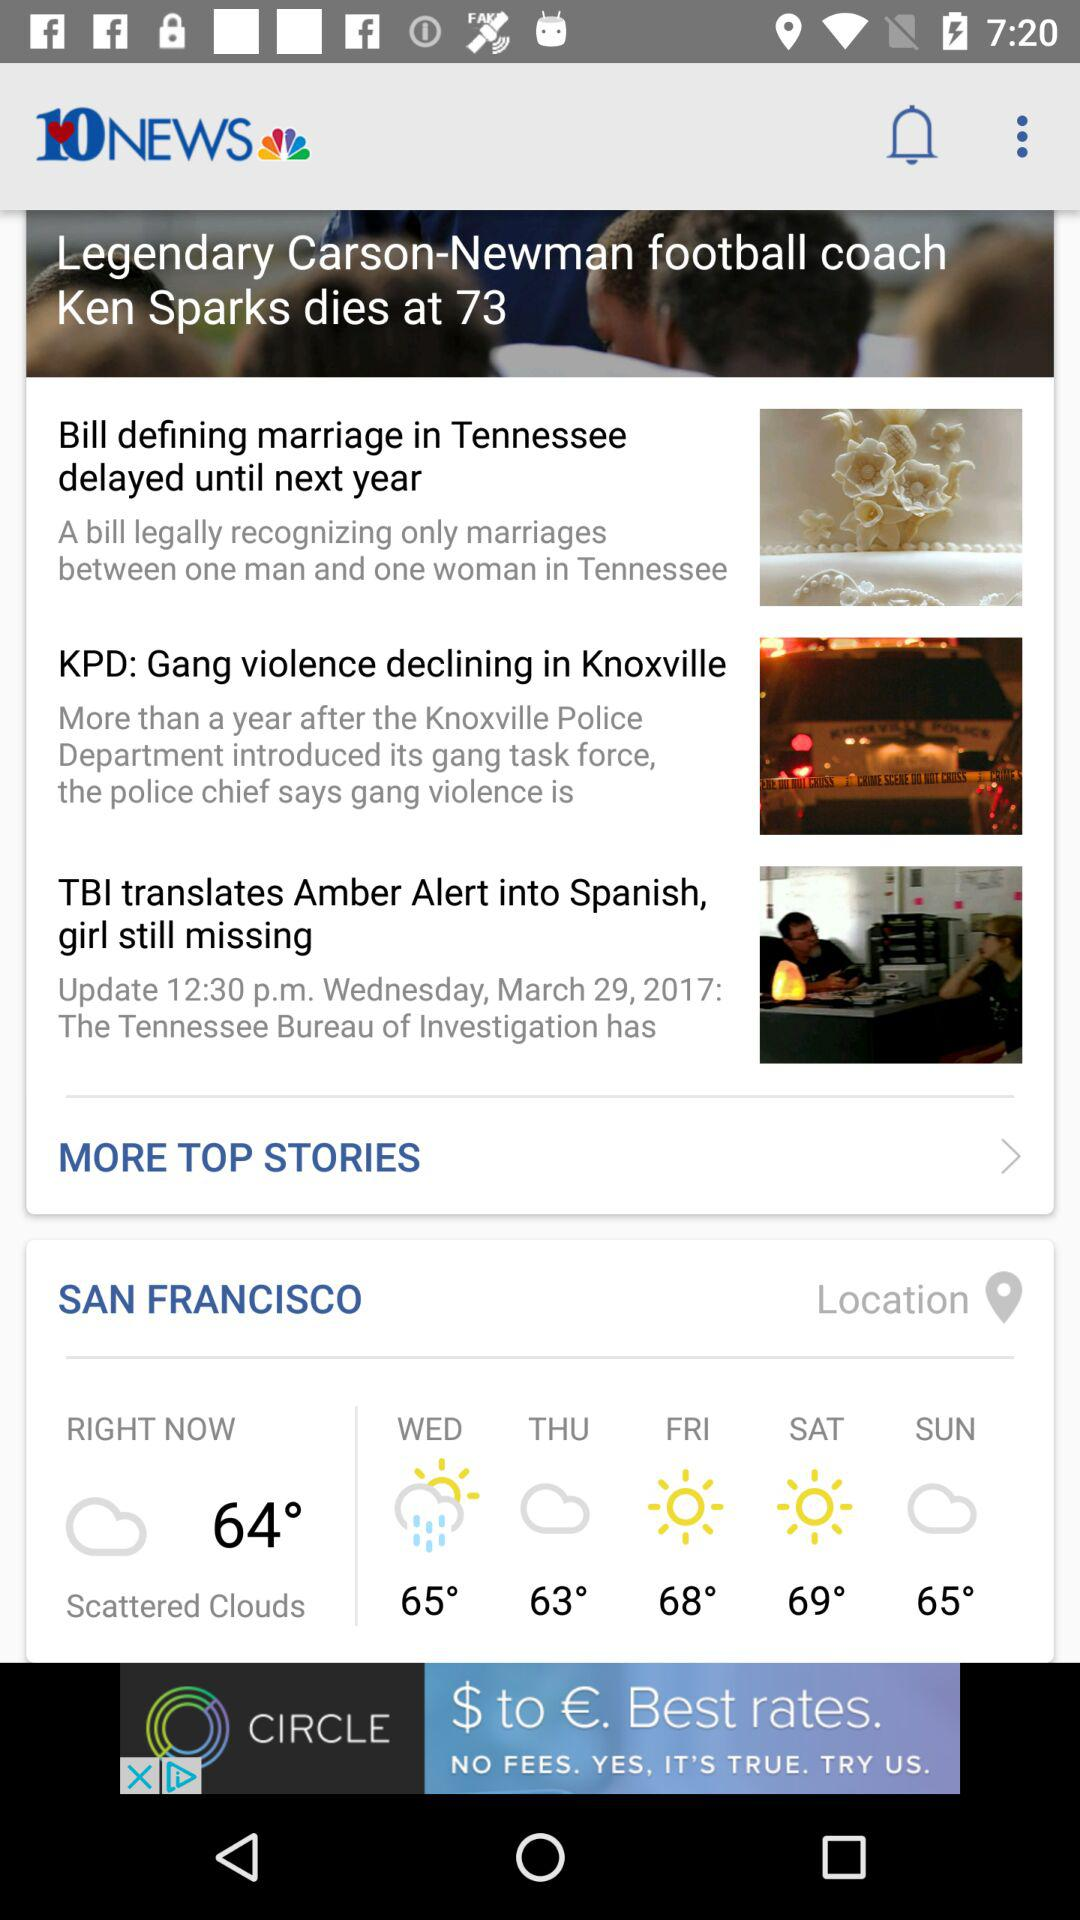How many stories are there in the news feed?
Answer the question using a single word or phrase. 4 